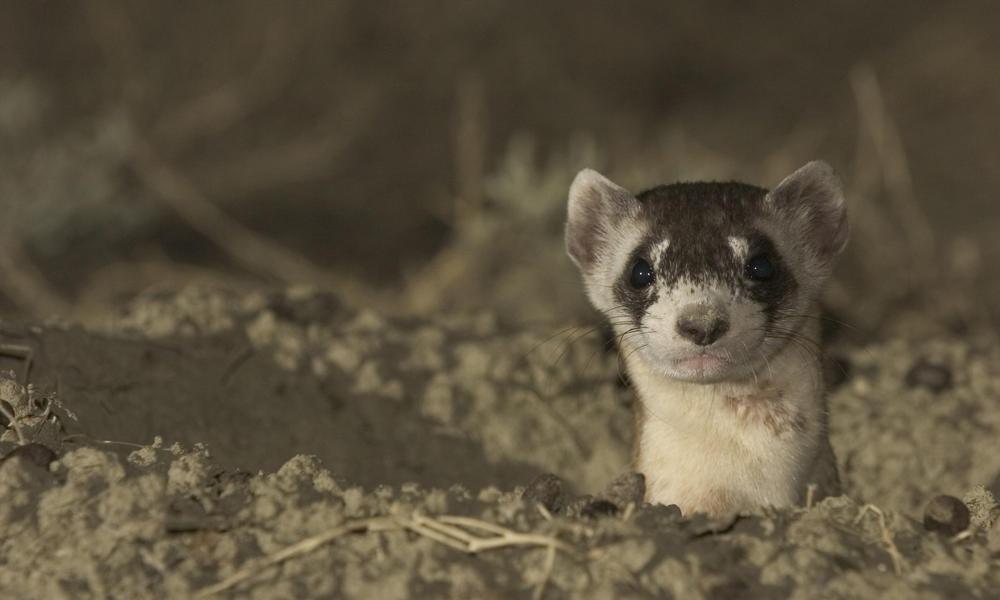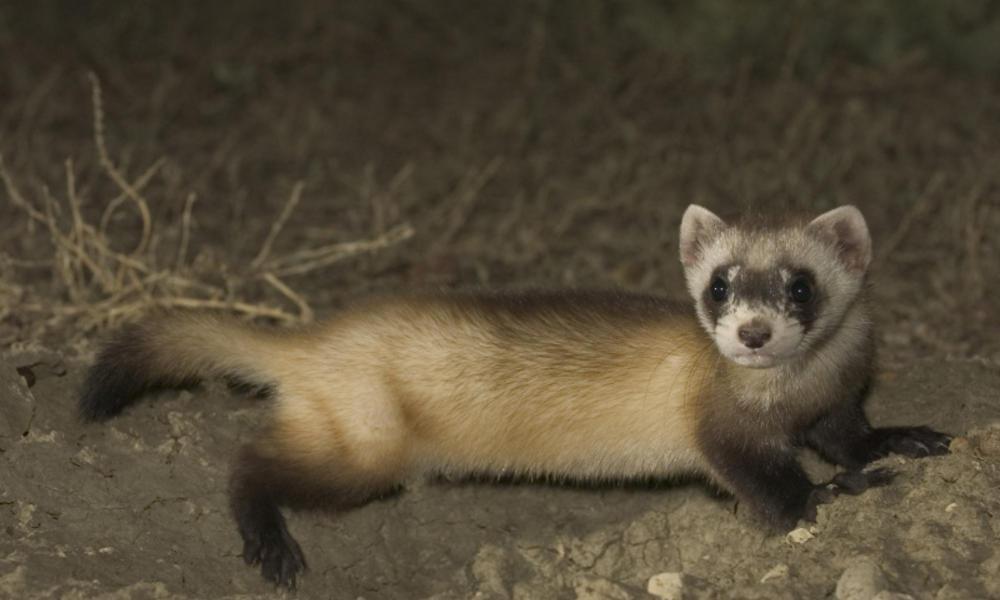The first image is the image on the left, the second image is the image on the right. Considering the images on both sides, is "Prairie dogs pose together in the image on the right." valid? Answer yes or no. No. 